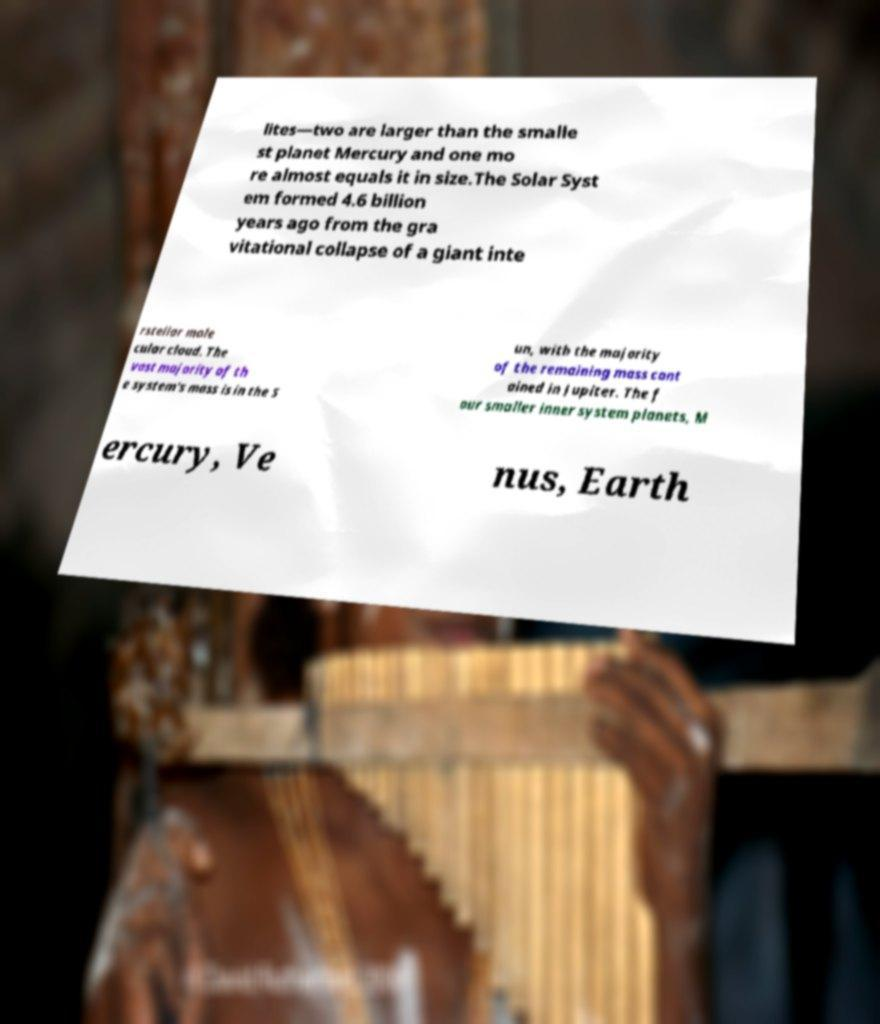Can you accurately transcribe the text from the provided image for me? lites—two are larger than the smalle st planet Mercury and one mo re almost equals it in size.The Solar Syst em formed 4.6 billion years ago from the gra vitational collapse of a giant inte rstellar mole cular cloud. The vast majority of th e system's mass is in the S un, with the majority of the remaining mass cont ained in Jupiter. The f our smaller inner system planets, M ercury, Ve nus, Earth 